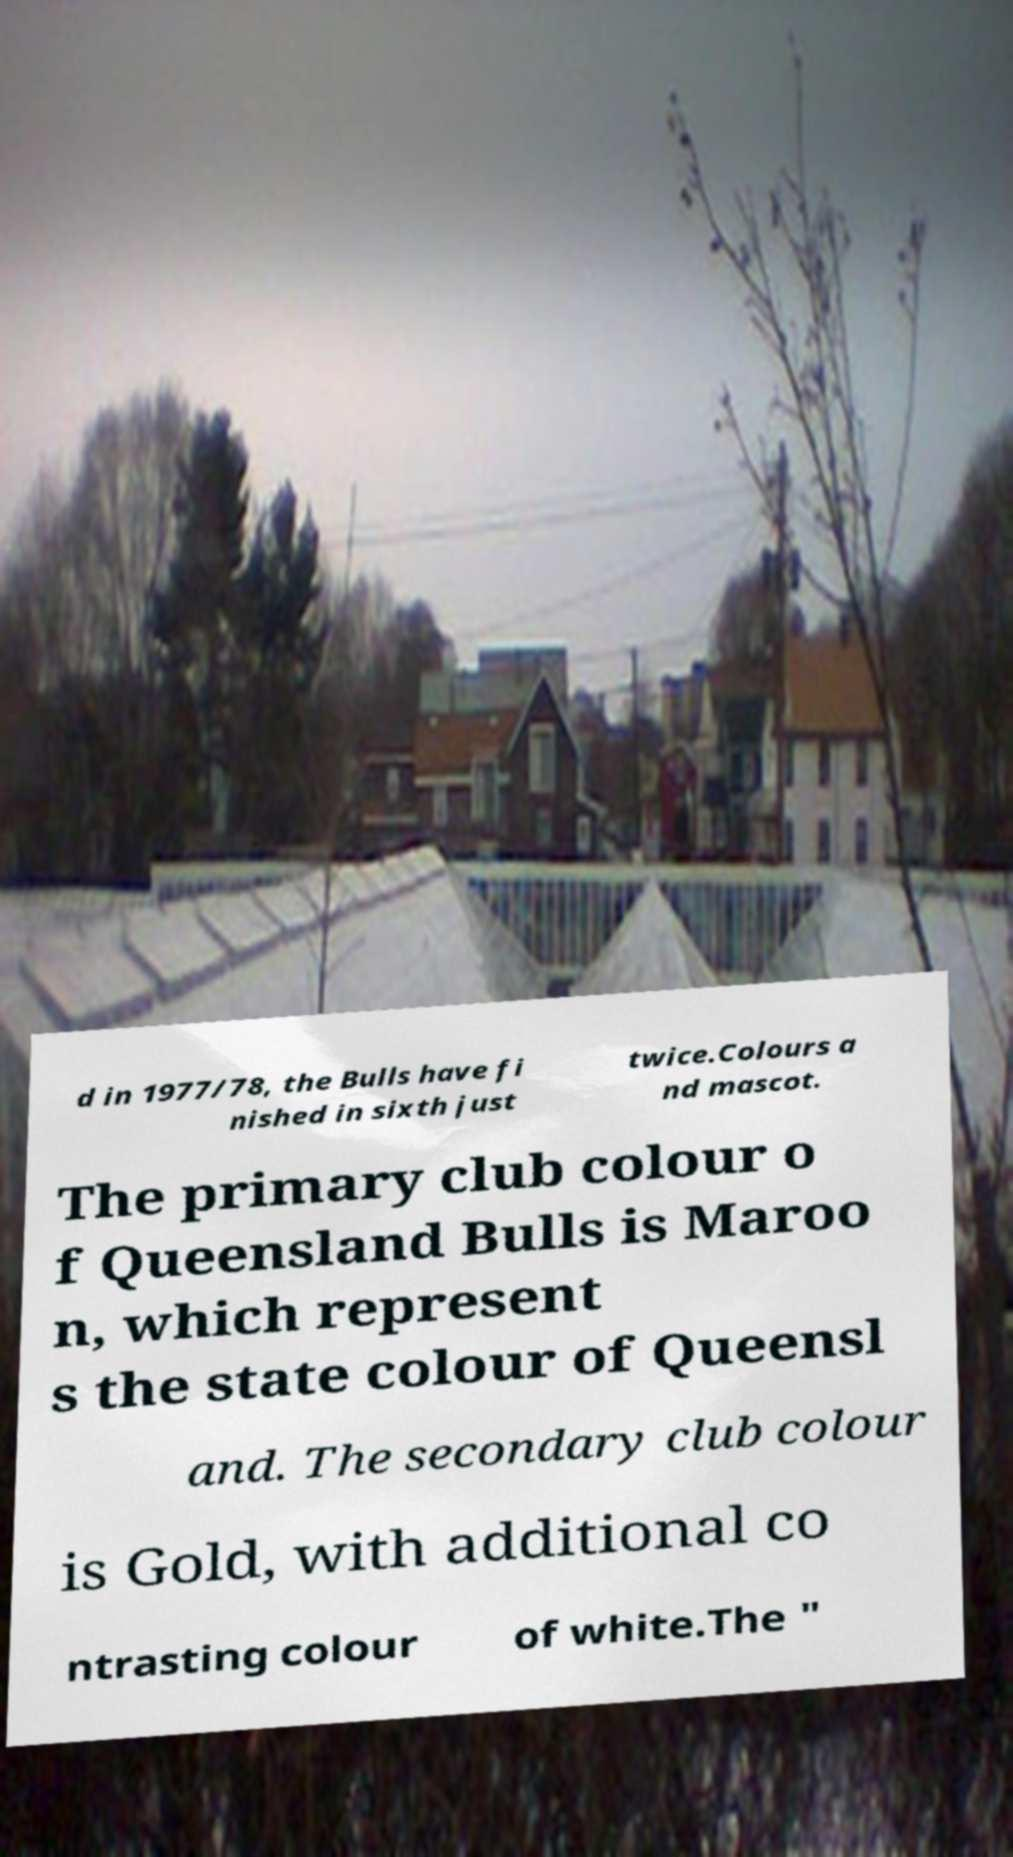There's text embedded in this image that I need extracted. Can you transcribe it verbatim? d in 1977/78, the Bulls have fi nished in sixth just twice.Colours a nd mascot. The primary club colour o f Queensland Bulls is Maroo n, which represent s the state colour of Queensl and. The secondary club colour is Gold, with additional co ntrasting colour of white.The " 